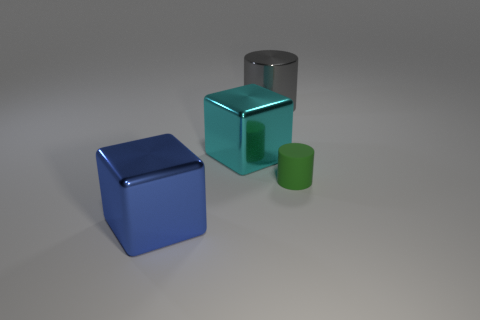Add 4 large rubber spheres. How many objects exist? 8 Subtract 1 blocks. How many blocks are left? 1 Subtract all gray cylinders. How many cylinders are left? 1 Subtract 0 green blocks. How many objects are left? 4 Subtract all blue cubes. Subtract all cyan cylinders. How many cubes are left? 1 Subtract all purple spheres. How many blue cubes are left? 1 Subtract all big cyan metallic objects. Subtract all small matte cylinders. How many objects are left? 2 Add 1 large cyan shiny cubes. How many large cyan shiny cubes are left? 2 Add 1 tiny blue cylinders. How many tiny blue cylinders exist? 1 